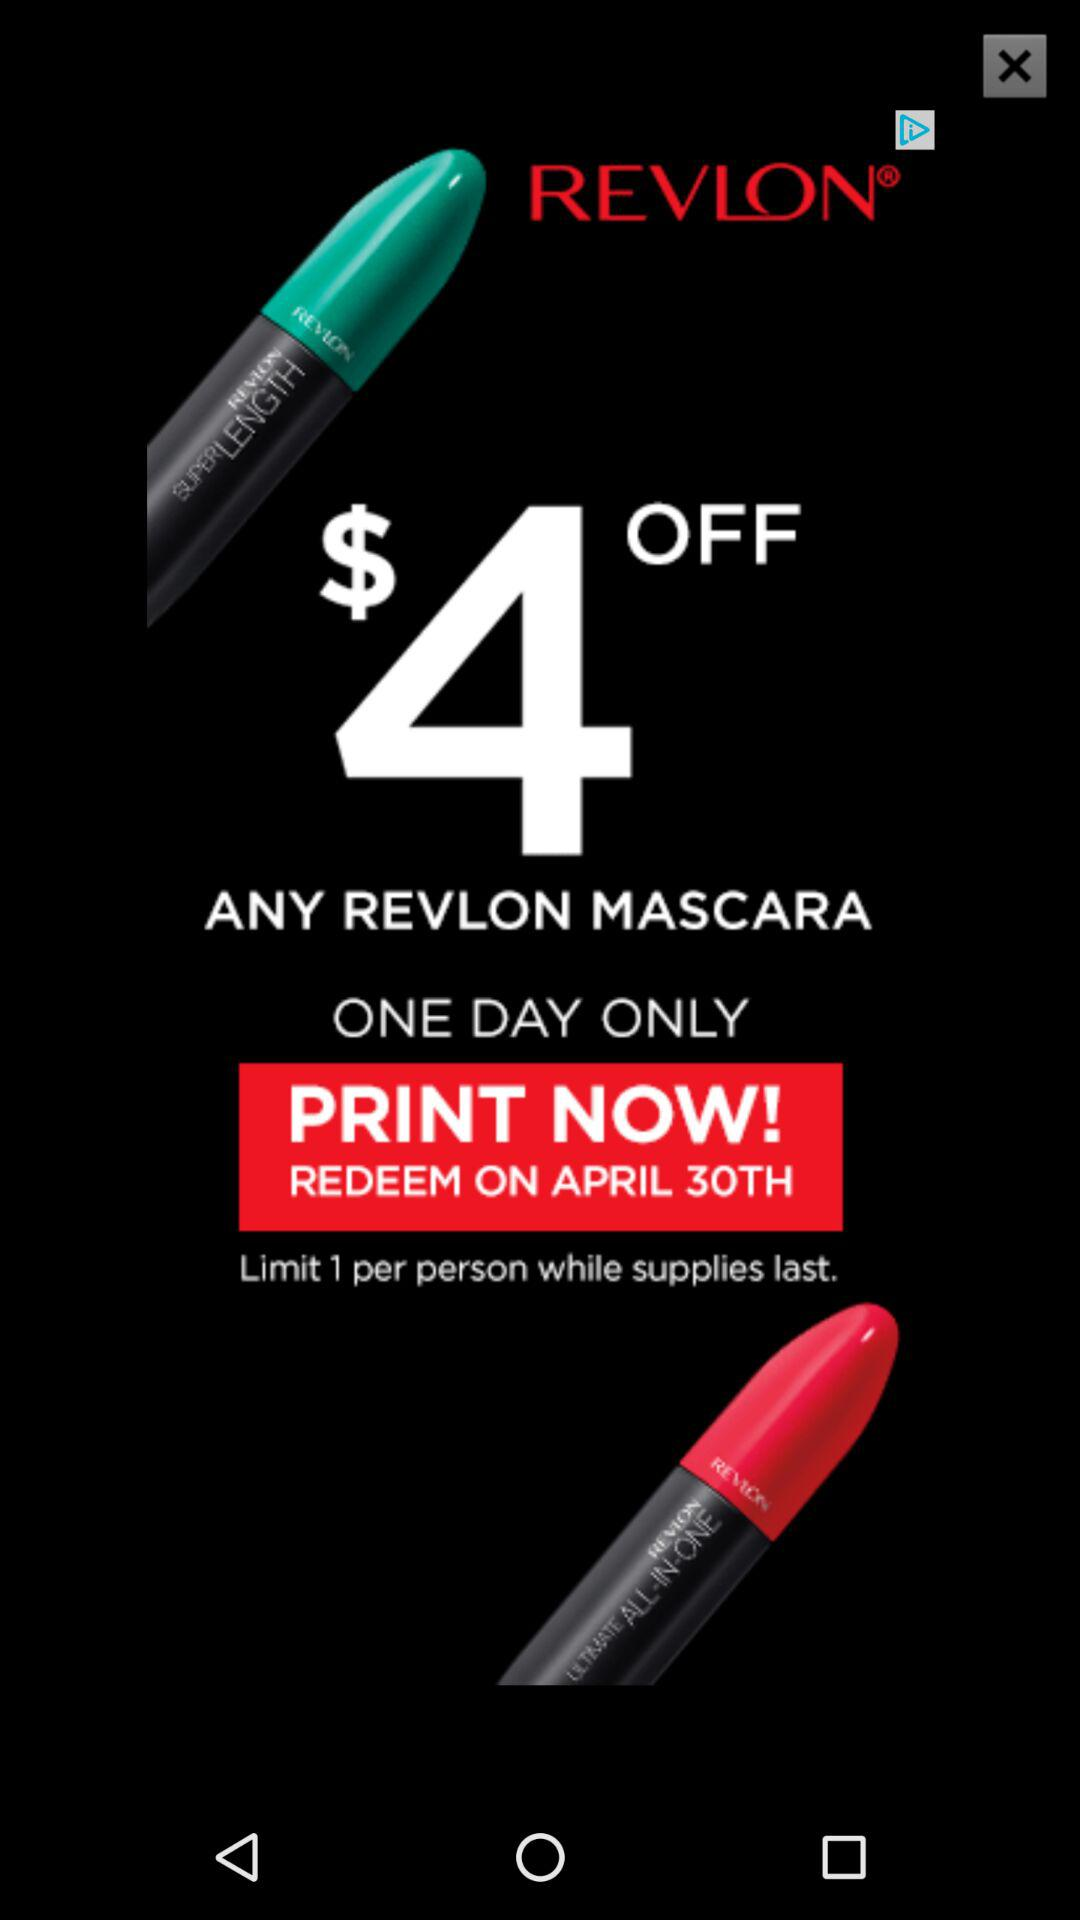How much money do I save if I purchase the mascara?
Answer the question using a single word or phrase. $4 